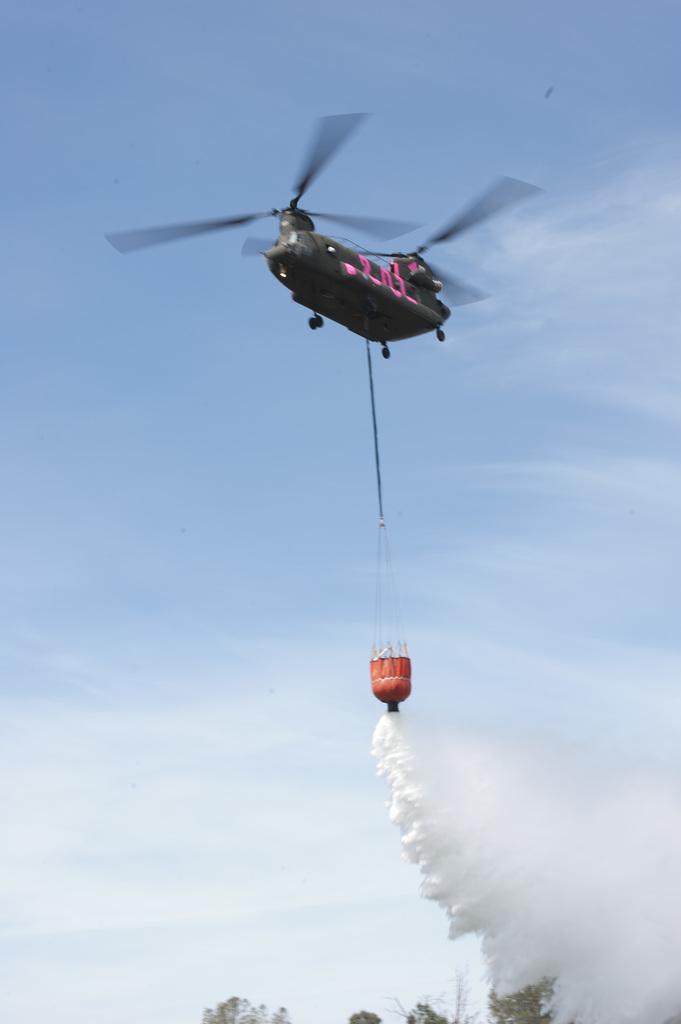Can you describe this image briefly? In this picture we can see an object, rope, smoke, helicopter, trees and in the background we can see the sky. 